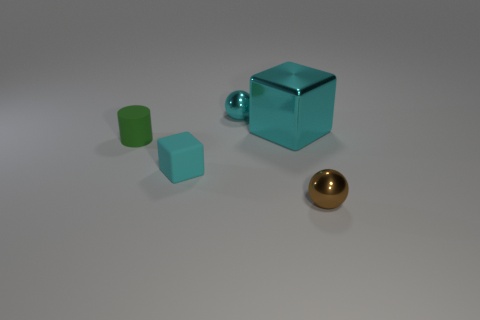Add 4 big yellow matte cylinders. How many objects exist? 9 Subtract all cubes. How many objects are left? 3 Add 2 small matte objects. How many small matte objects are left? 4 Add 1 tiny cyan objects. How many tiny cyan objects exist? 3 Subtract 1 cyan spheres. How many objects are left? 4 Subtract all big metallic cubes. Subtract all big cyan shiny objects. How many objects are left? 3 